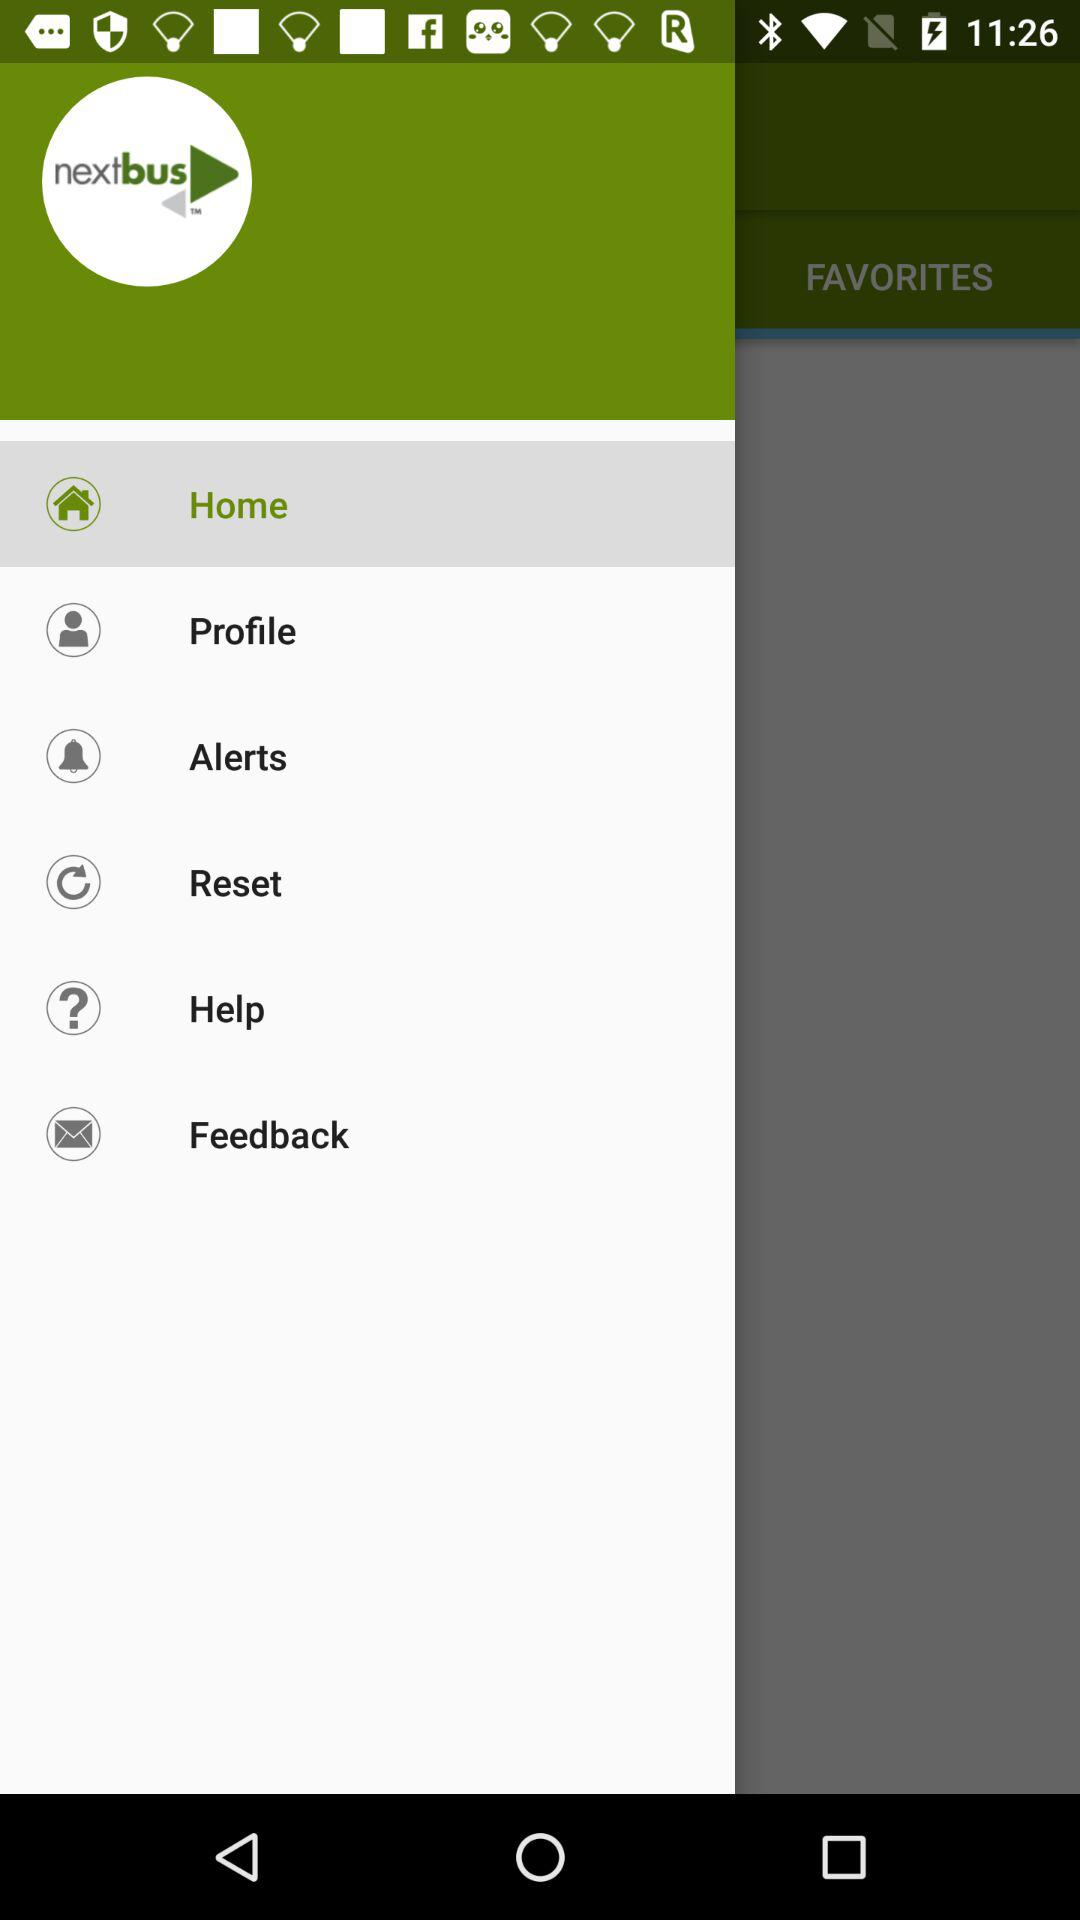What is the name of the application? The name of the application is "nextbus". 